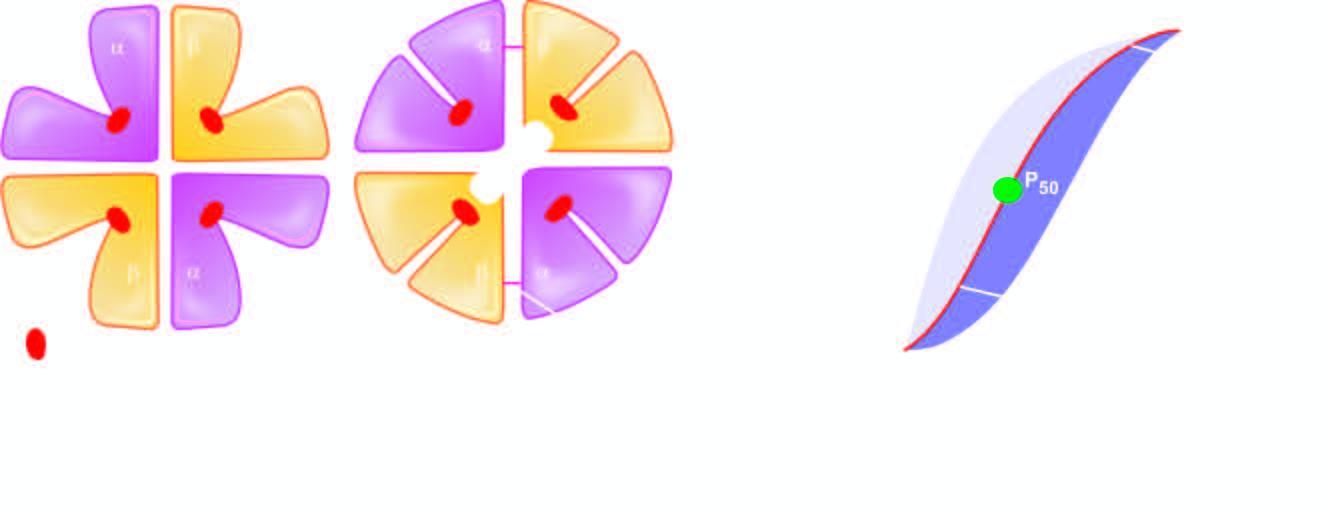s the apex less with high ph, low 2,3-bpg and hbf?
Answer the question using a single word or phrase. No 